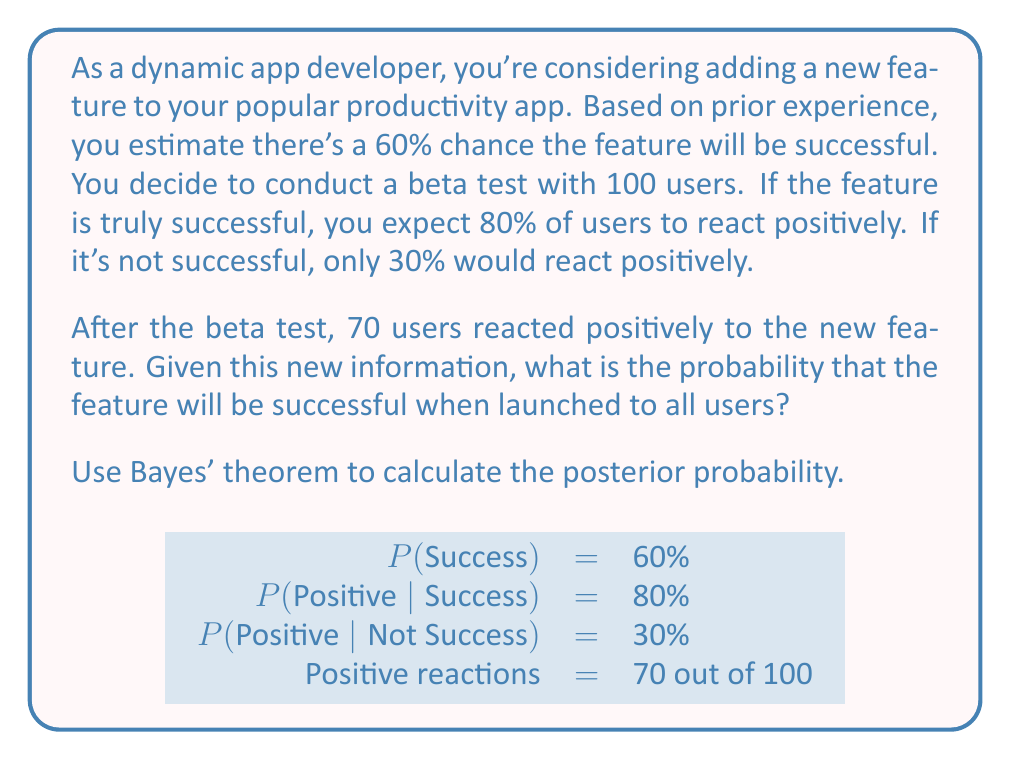Solve this math problem. Let's approach this step-by-step using Bayes' theorem:

1) Define our events:
   S: The feature is successful
   D: The observed data (70 out of 100 users reacted positively)

2) We need to calculate P(S|D) using Bayes' theorem:

   $$P(S|D) = \frac{P(D|S) \cdot P(S)}{P(D)}$$

3) We know:
   P(S) = 0.60 (prior probability of success)
   P(D|S) = P(70 positive reactions out of 100 users, given success)
   
4) Calculate P(D|S) using the binomial probability formula:
   $$P(D|S) = \binom{100}{70} (0.80)^{70} (0.20)^{30} \approx 0.0485$$

5) Calculate P(D|not S):
   $$P(D|not S) = \binom{100}{70} (0.30)^{70} (0.70)^{30} \approx 1.03 \times 10^{-11}$$

6) Calculate P(D) using the law of total probability:
   $$P(D) = P(D|S) \cdot P(S) + P(D|not S) \cdot P(not S)$$
   $$P(D) = 0.0485 \cdot 0.60 + (1.03 \times 10^{-11}) \cdot 0.40 \approx 0.0291$$

7) Now we can apply Bayes' theorem:
   $$P(S|D) = \frac{0.0485 \cdot 0.60}{0.0291} \approx 0.9999$$

Therefore, given the positive user feedback, the probability that the feature will be successful when launched to all users is approximately 99.99%.
Answer: 0.9999 or 99.99% 